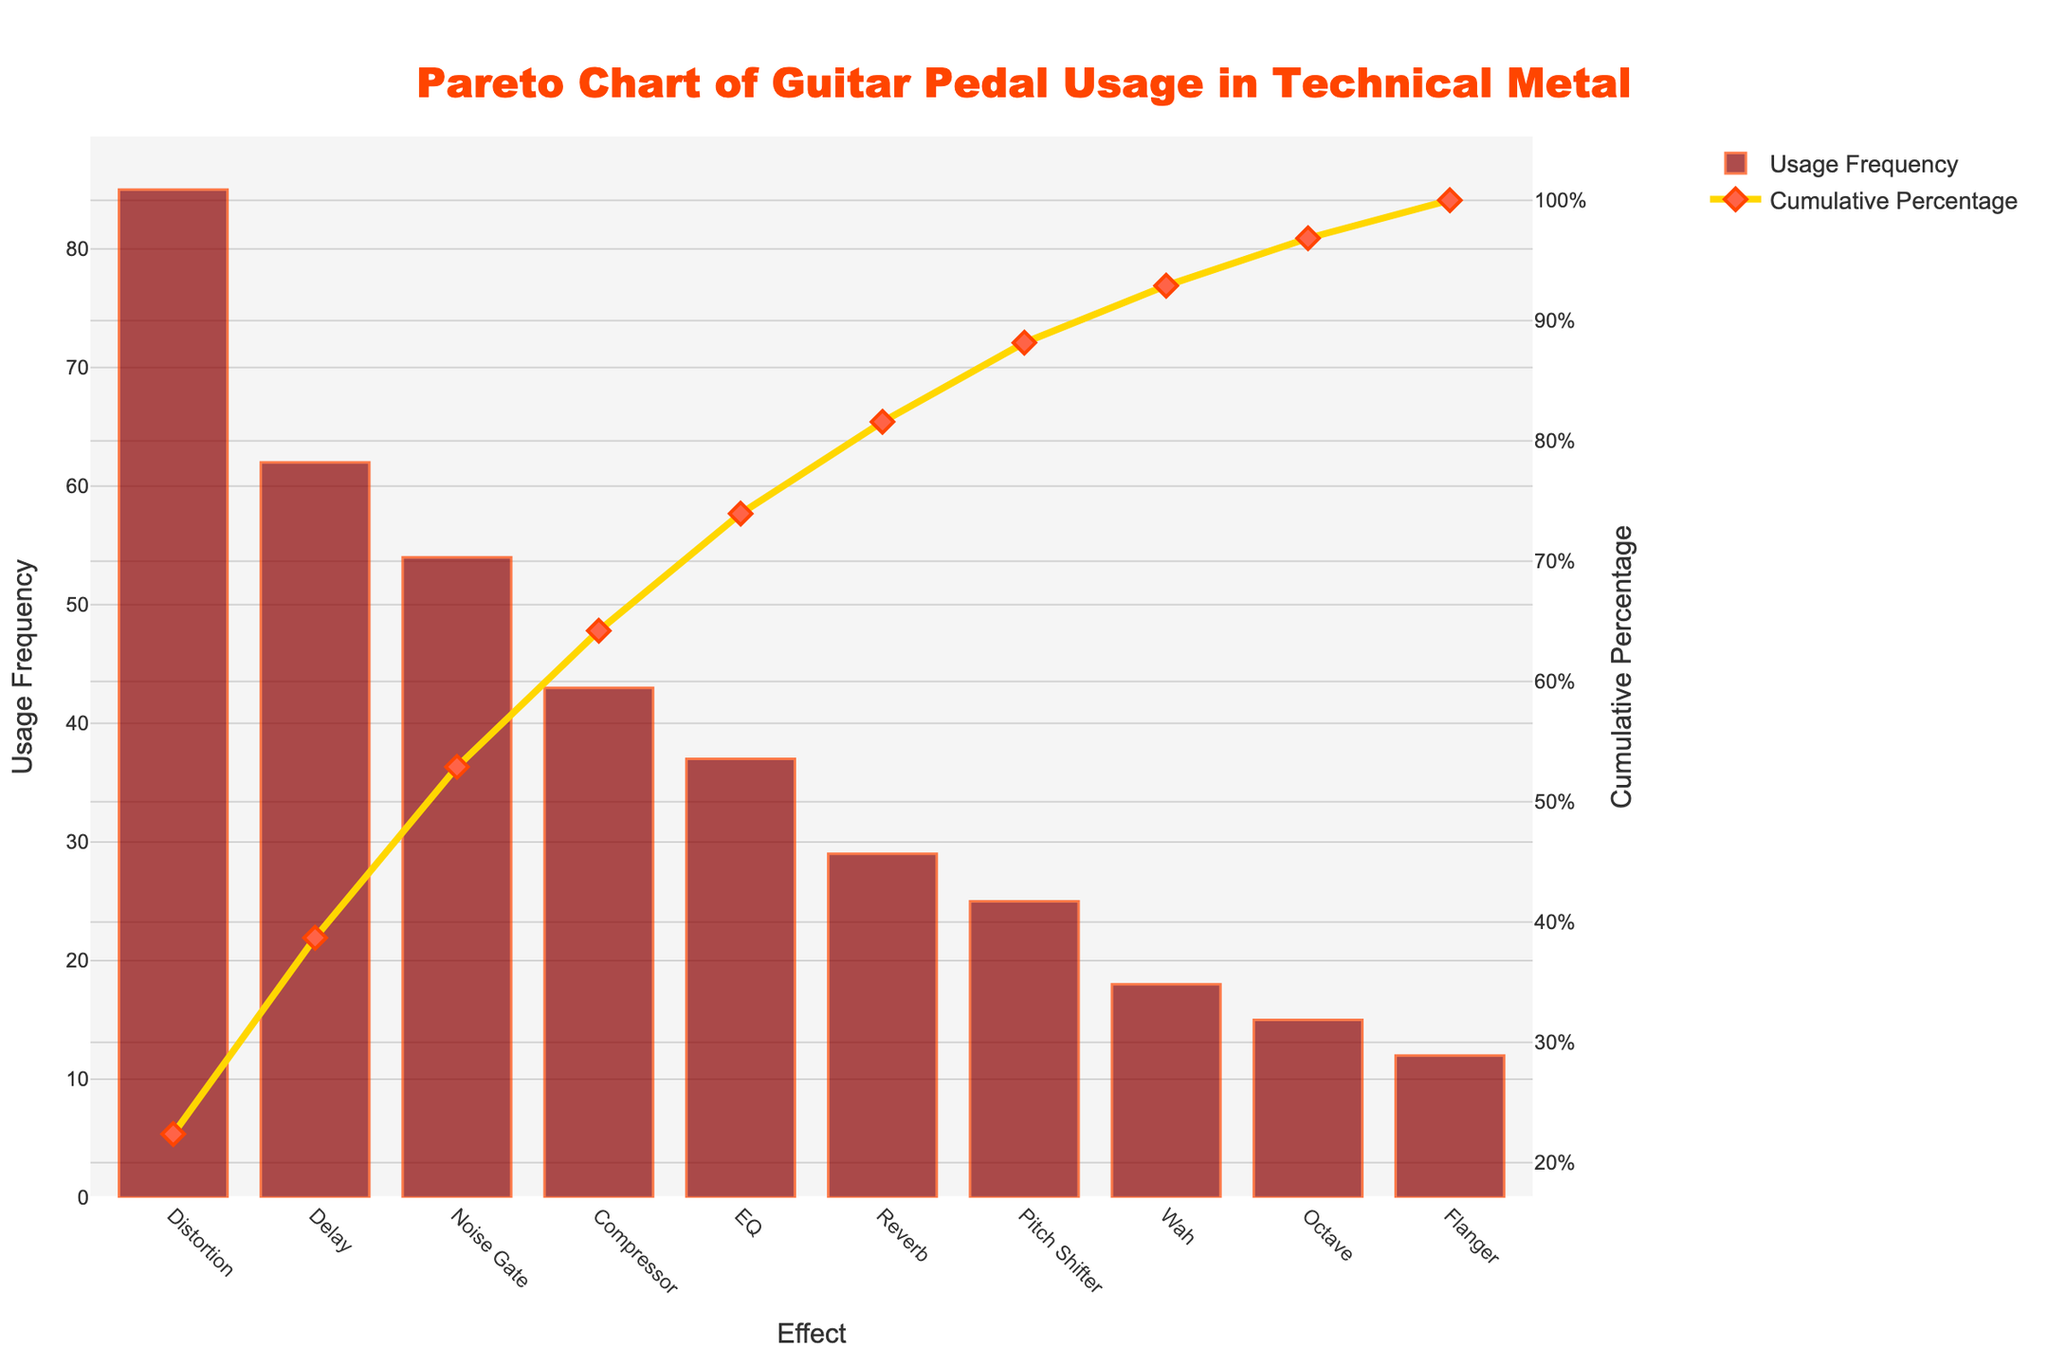How many effects are represented in the chart? The title and the x-axis show that the chart is about usage frequency of guitar pedals categorized by their effects. By counting the distinct labels on the x-axis, we determine there are 10 effects represented.
Answer: 10 Which effect is used most frequently? By observing the height of the bars, it is clear that the "Distortion" bar is the tallest among all. Hence, "Distortion" is the most frequently used effect.
Answer: Distortion What cumulative percentage does the "Noise Gate" effect reach? The line trace represents the cumulative percentage. By following the line marker corresponding to the "Noise Gate" effect and reading the value on the right y-axis, it shows that the cumulative percentage is 69.7%.
Answer: 69.7% Compare the usage frequency of "Compressor" and "Reverb". Which one is higher? By comparing the heights of the bars for "Compressor" and "Reverb", we see that "Compressor" has a taller bar. Therefore, "Compressor" is used more frequently.
Answer: Compressor What is the total usage frequency for the top three effects combined? The top three effects are "Distortion", "Delay", and "Noise Gate" with frequencies 85, 62, and 54 respectively. Adding these frequencies together, the total is 85 + 62 + 54 = 201.
Answer: 201 What is the cumulative percentage after the "EQ" effect? By following the line marker for the "EQ" effect and checking the corresponding value on the right y-axis, the cumulative percentage is 75.8%.
Answer: 75.8% Which effect has the least usage frequency, and what is its frequency? By identifying the shortest bar on the chart, "Flanger" has the least usage frequency. Reading its bar height, the frequency is 12.
Answer: Flanger, 12 How many effects are required to reach a cumulative percentage of over 80%? By observing the cumulative percentage line, we find that reaching over 80% requires including the top four effects: "Distortion", "Delay", "Noise Gate", and "Compressor". By including "EQ", the cumulative reaches 81.9%. Thus, five effects are needed.
Answer: 5 What is the difference in usage frequency between "Pitch Shifter" and "Wah"? The bar heights for "Pitch Shifter" and "Wah" are 25 and 18 respectively. The difference is calculated as 25 - 18 = 7.
Answer: 7 What percentage of the total usage do the bottom three effects represent together? The bottom three effects are "Wah", "Octave", and "Flanger" with frequencies 18, 15, and 12 respectively. Adding these gives 18 + 15 + 12 = 45. The total usage frequency is the sum of all frequencies, which is 380. Thus, the percentage is (45 / 380) * 100 ≈ 11.8%.
Answer: 11.8% 